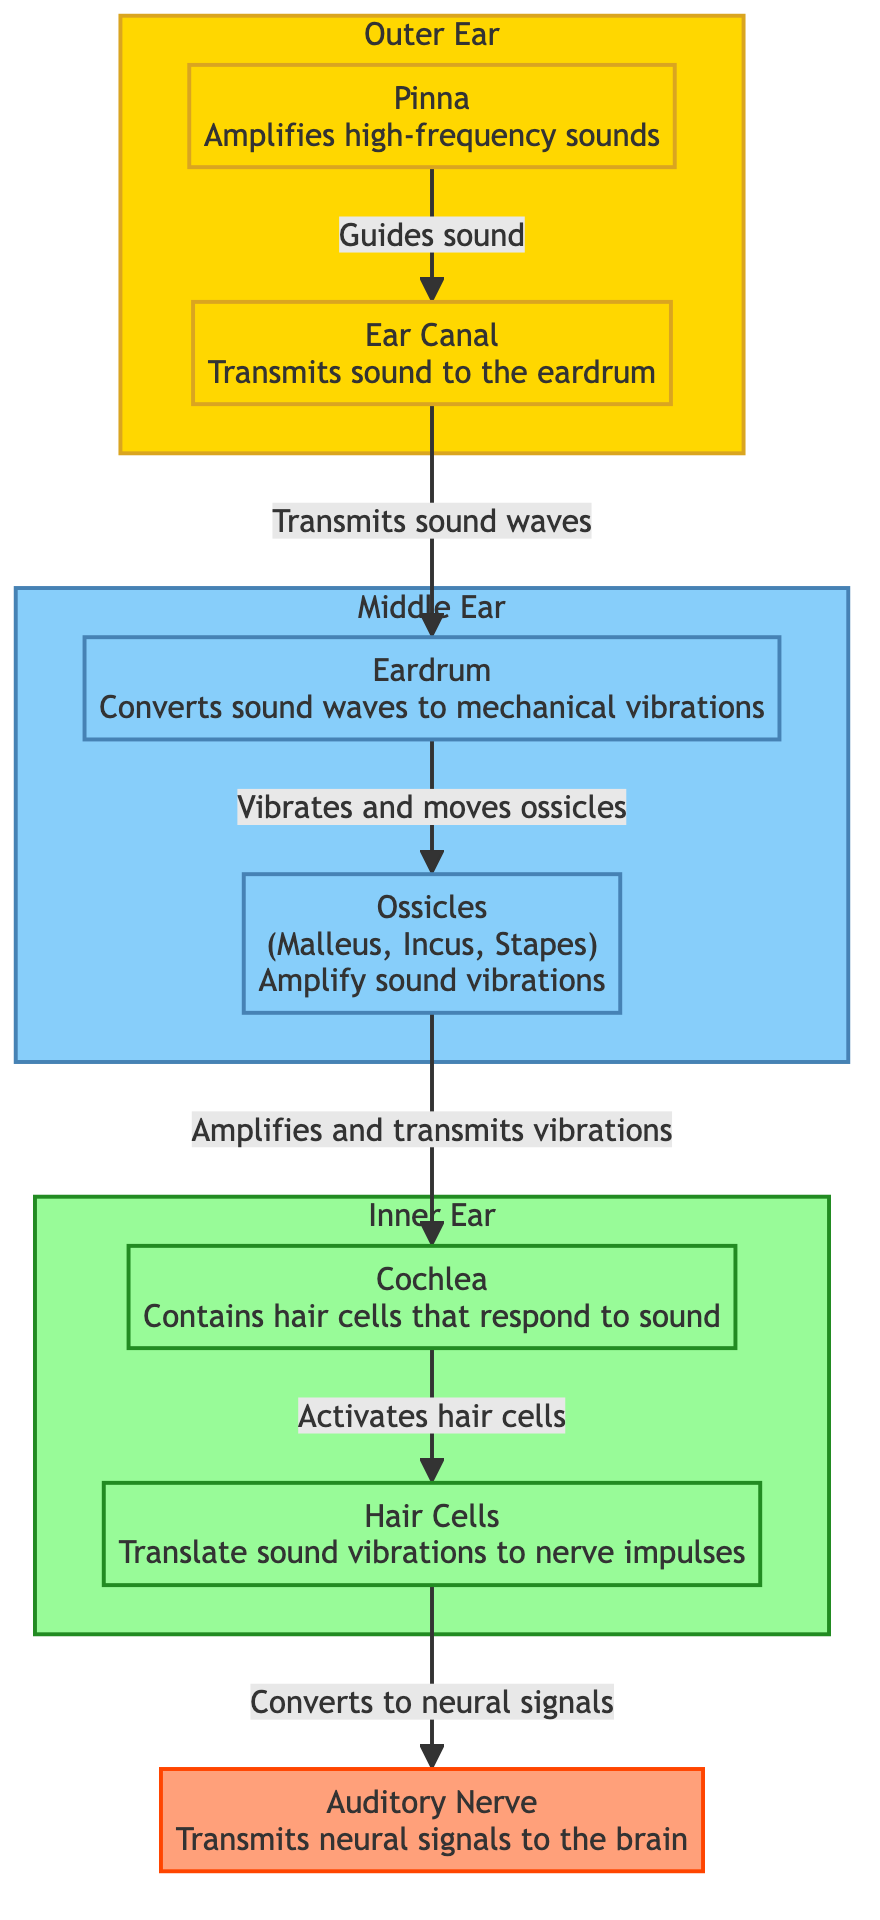What is the function of the Pinna? The Pinna amplifies high-frequency sounds, as indicated in the diagram next to the Pinna label.
Answer: Amplifies high-frequency sounds How many ossicles are there? The diagram specifies the ossicles include Malleus, Incus, and Stapes, indicating there are three ossicles.
Answer: Three What does the Eardrum convert? According to the label beside the Eardrum, it converts sound waves into mechanical vibrations.
Answer: Sound waves to mechanical vibrations Which structure contains hair cells? The diagram indicates that the Cochlea contains hair cells.
Answer: Cochlea How does sound travel from the Ear Canal to the Eardrum? The diagram shows a direct connection from the Ear Canal to the Eardrum, indicating sound is transmitted directly between these structures.
Answer: Transmits sound waves What is the role of Hair Cells? Hair Cells translate sound vibrations to nerve impulses, as stated in the diagram next to the Hair Cells label.
Answer: Translate sound vibrations to nerve impulses What amplifies sound vibrations after the Eardrum? The diagram shows that the Ossicles amplify sound vibrations after the Eardrum.
Answer: Ossicles What is the final step in the auditory pathway according to the diagram? Following the flow of the diagram, the final step is the Auditory Nerve transmitting neural signals to the brain.
Answer: Auditory Nerve Which structures are classified as the middle ear? The diagram defines the middle ear to include the Eardrum and Ossicles.
Answer: Eardrum and Ossicles 